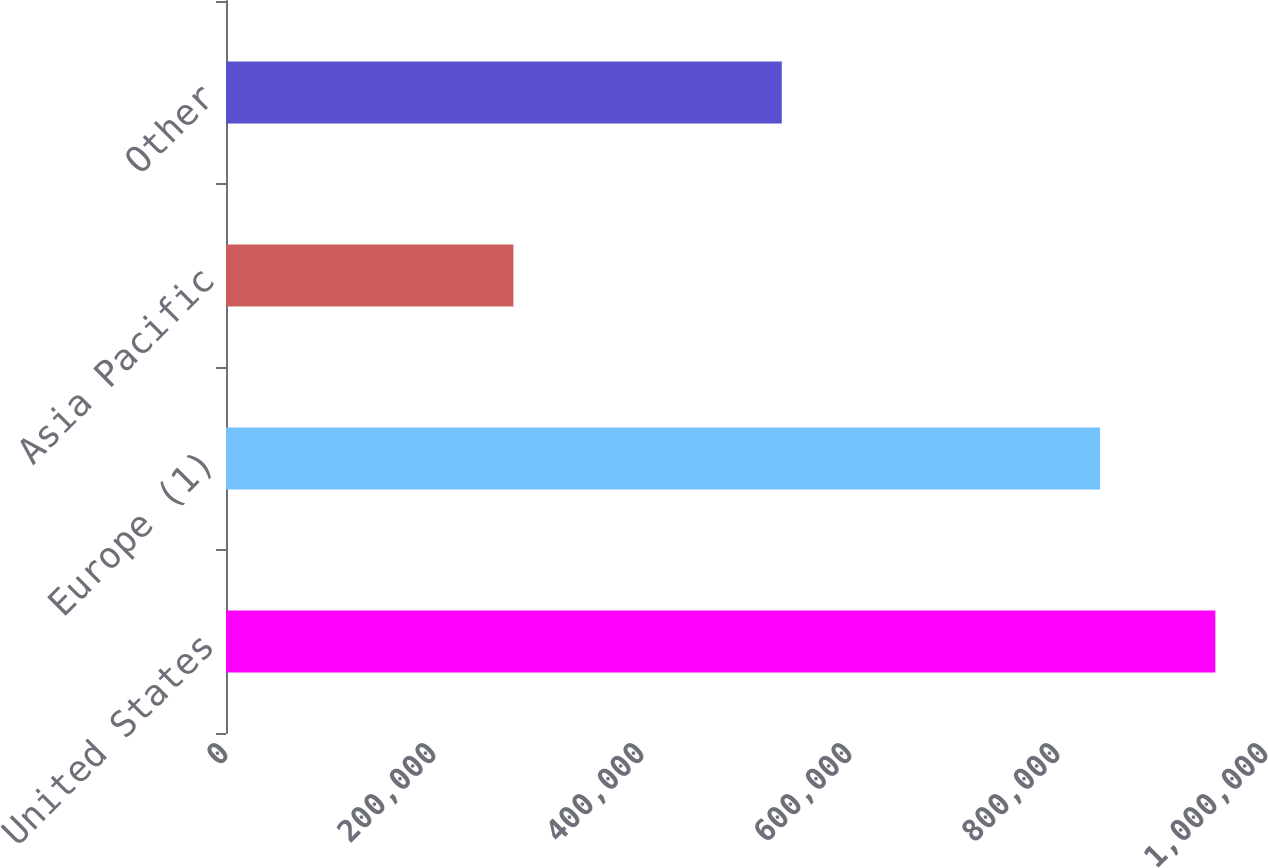Convert chart. <chart><loc_0><loc_0><loc_500><loc_500><bar_chart><fcel>United States<fcel>Europe (1)<fcel>Asia Pacific<fcel>Other<nl><fcel>951307<fcel>840465<fcel>276350<fcel>534410<nl></chart> 